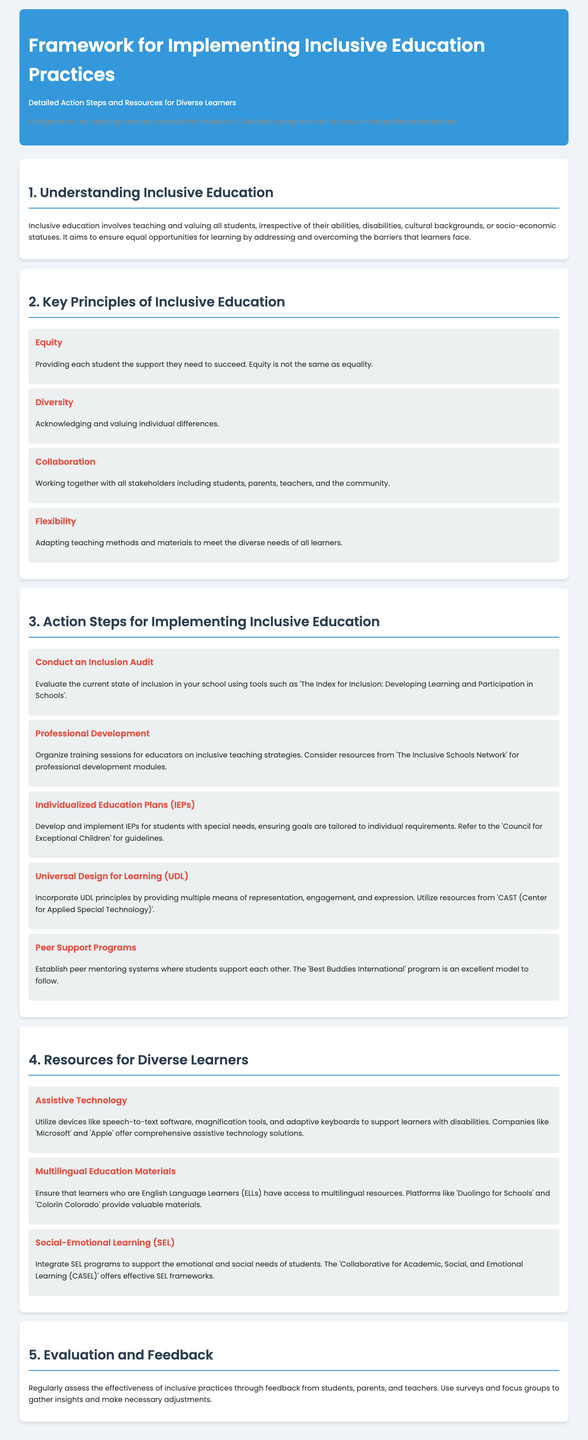What is the title of the framework? The title of the framework is the main heading at the top of the document, summarizing its purpose.
Answer: Framework for Implementing Inclusive Education Practices Who is the intended audience for this document? The intended audience is specified in the persona section, indicating who the document is designed for.
Answer: An aspiring educator What are the four key principles of inclusive education? The principles are listed under key principles and provide a framework for inclusive practices.
Answer: Equity, Diversity, Collaboration, Flexibility What is the first action step for implementing inclusive education? The first action step is mentioned in the action steps section as part of the process to evaluate current practices.
Answer: Conduct an Inclusion Audit Which organization is mentioned as a resource for developing IEPs? The resource is referenced in connection with guidelines for creating individualized education plans.
Answer: Council for Exceptional Children What type of technology is suggested to support learners with disabilities? The technology is highlighted in the resource section, specifically to aid students facing challenges.
Answer: Assistive Technology What does SEL stand for in the context of resources mentioned? SEL is an abbreviation provided in the resources section related to student support programs.
Answer: Social-Emotional Learning How does the document suggest evaluating inclusive practices? This evaluation method is detailed in the last section, recommending methods for assessing effectiveness.
Answer: Regularly assess the effectiveness through feedback What is the last section of the document about? The last section summarizes what should be done to maintain and improve inclusion practices in schools.
Answer: Evaluation and Feedback 